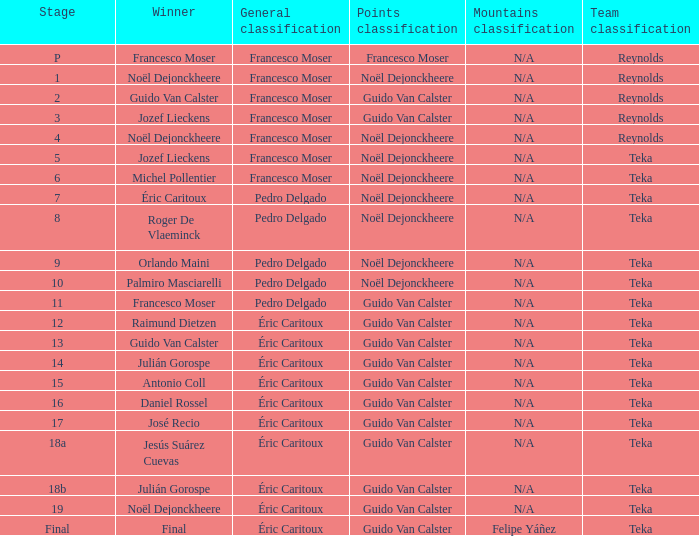Name the points classification for stage of 18b Guido Van Calster. 